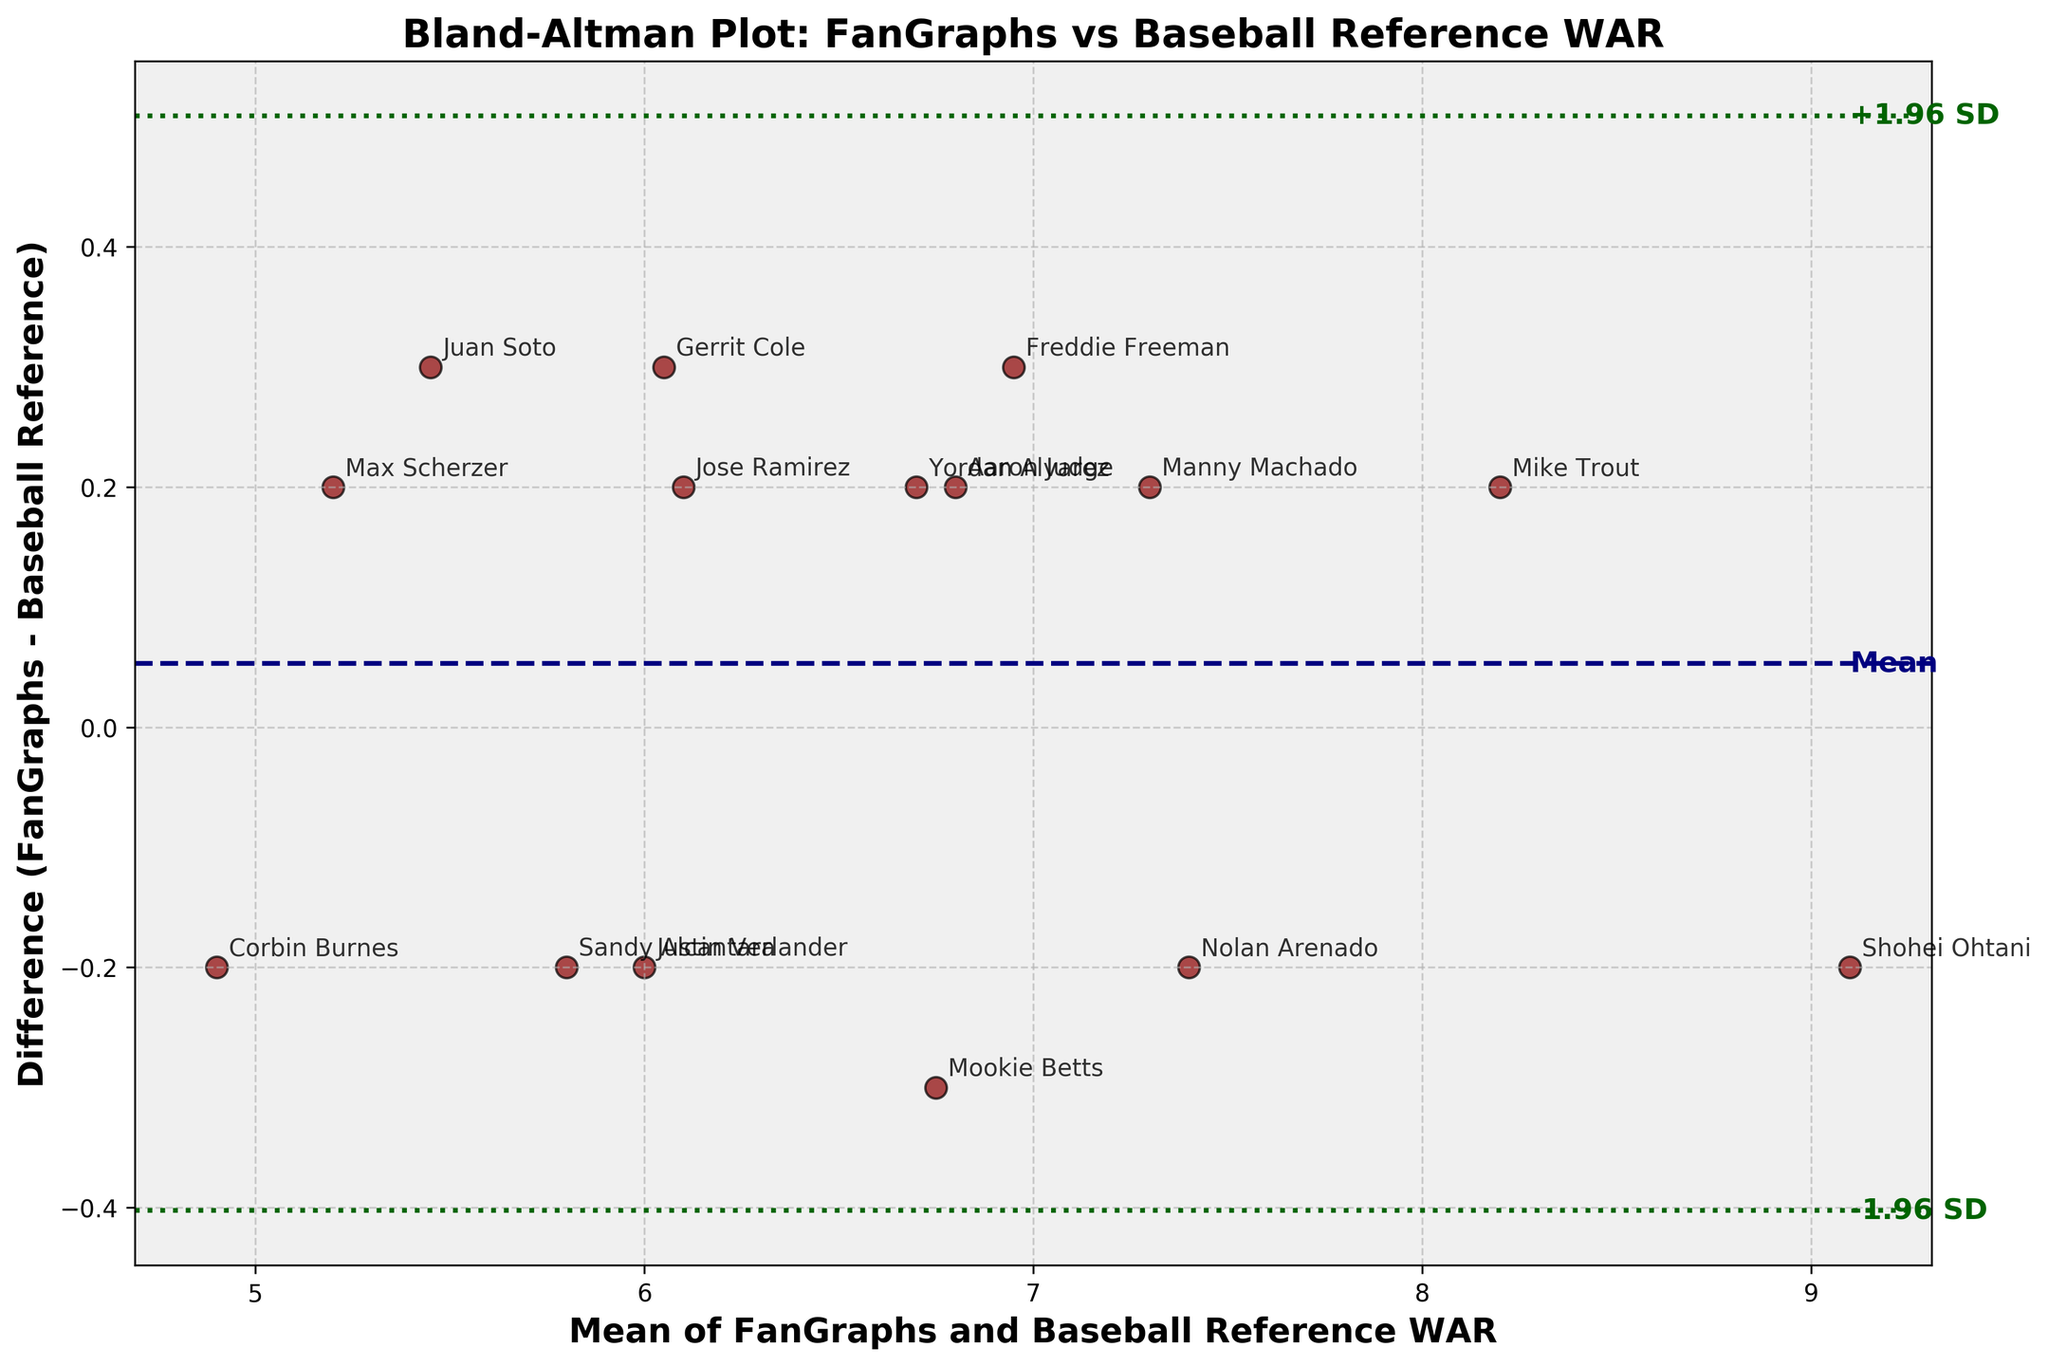What's the title of the plot? The title of the figure is displayed prominently at the top. In this Bland-Altman plot, it reads 'Bland-Altman Plot: FanGraphs vs Baseball Reference WAR'.
Answer: Bland-Altman Plot: FanGraphs vs Baseball Reference WAR How many baseball players' WAR data points are plotted? Each point on the Bland-Altman plot corresponds to one baseball player, and there is a marker for each entry in the provided data. Counting these markers will reveal the total number, which matches the number of rows in the data table.
Answer: 15 What color and style are the lines representing the mean difference? The line representing the mean difference is of a specific color and style. In the plot, this line is navy and dashed, which helps distinguish it from the limits of agreement lines.
Answer: Navy and dashed How do the limits of agreement lines differ visually from the mean difference line? The figure shows that the limits of agreement lines have a different style to distinguish them clearly. They are dark green and dotted in contrast to the dashed navy mean difference line.
Answer: Dark green and dotted Which player has the highest mean WAR between FanGraphs and Baseball Reference? By examining the x-axis for the highest mean value, we identify the player associated with this data point. The mean WAR is calculated by averaging the FanGraphs and Baseball Reference WAR values. Shohei Ohtani, with WAR values of 9.0 and 9.2, respectively, shows the highest average.
Answer: Shohei Ohtani What is the mean difference in WAR between FanGraphs and Baseball Reference? The mean difference is indicated by the horizontal dashed navy line on the plot. It represents the average difference between FanGraphs and Baseball Reference WAR values across all players.
Answer: Close to zero Which two players show the largest negative difference in their WAR values? The largest negative difference is the point farthest below the mean difference line. By identifying the points and the players' names associated with them, we find Sandy Alcantara and Justin Verlander with differences of -0.2 and -0.2, respectively.
Answer: Sandy Alcantara and Justin Verlander Which player shows the largest positive difference in their WAR values? The largest positive difference is identified by the point farthest above the mean difference line. By finding the player name associated with this point, the largest positive difference is observed for Jose Ramirez with a difference of 0.2.
Answer: Jose Ramirez Are there any players whose WAR values are exactly the same between FanGraphs and Baseball Reference? Observing the plot where the difference is zero (the mean difference line), any data points exactly on this line represent players with identical WAR values from both sources. Noticing that no point lies exactly on the mean difference line confirms that no player's FanGraphs and Baseball Reference WAR values are the same.
Answer: No What's the range of the limits of agreement? The limits of agreement are represented by the dotted dark green lines above and below the mean difference line and can be calculated as ±1.96 times the standard deviation of the differences. These bounds are annotated on the plot.
Answer: Approximately -0.3 to 0.3 